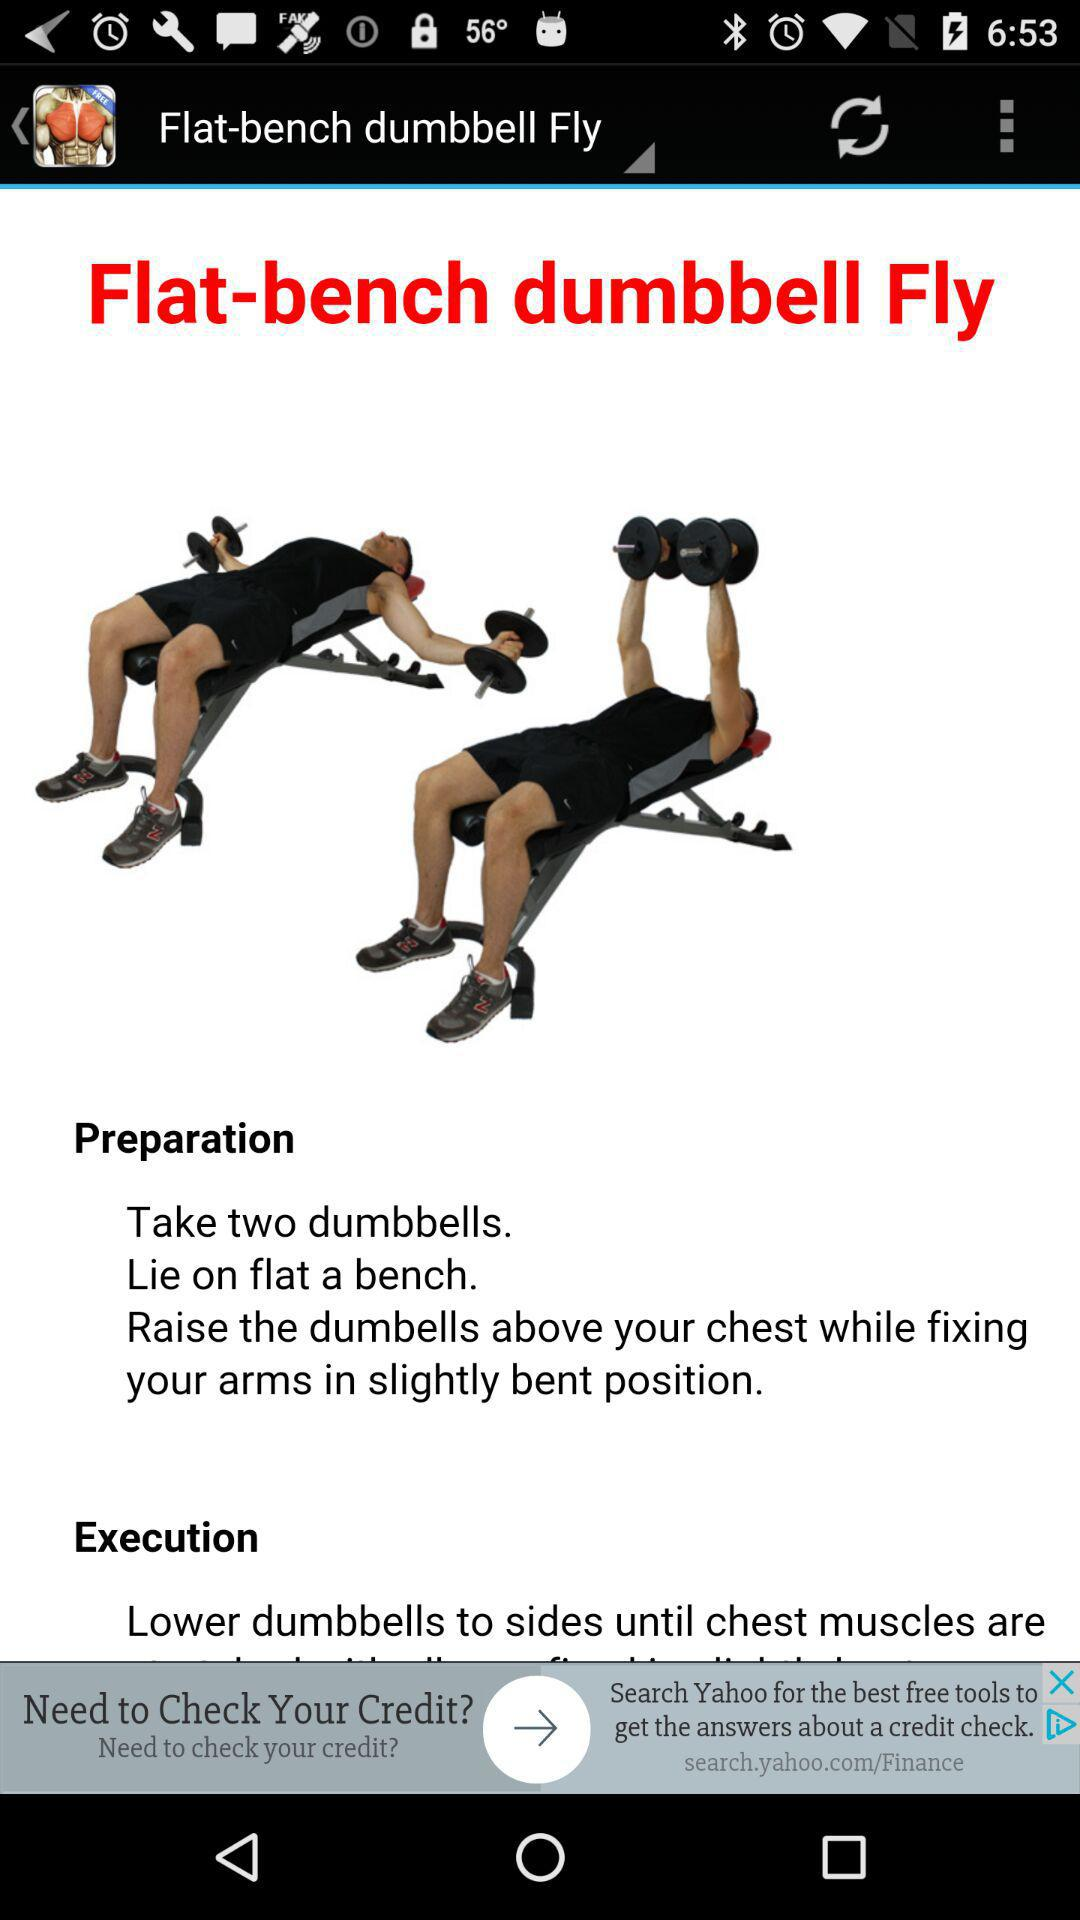How do I prepare for the flat-bench dumbbell fly? You can prepare for the flat-bench dumbbell fly by taking two dumbbells, lying on a flat bench, and raising the dumbbells above your chest while fixing your arms in the slightly bent position. 